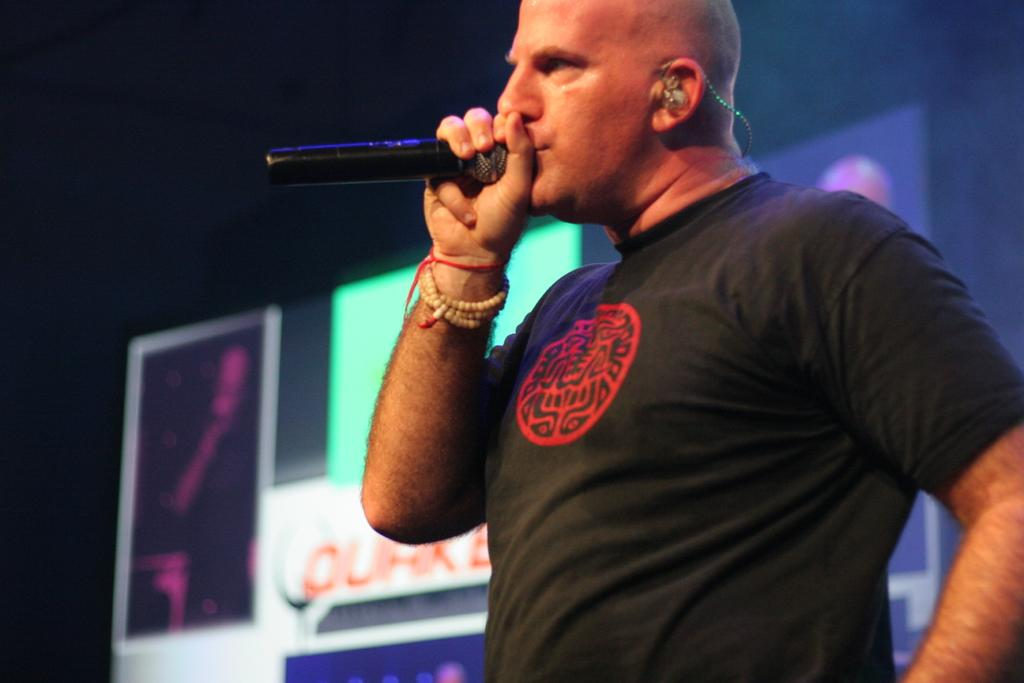What is the main subject of the image? There is a person standing in the center of the image. What is the person holding in his hand? The person is holding a mic in his hand. What can be seen in the background of the image? There are boards visible in the background of the image. How many women are present in the image? There is no mention of women in the image, so it cannot be determined from the facts provided. 